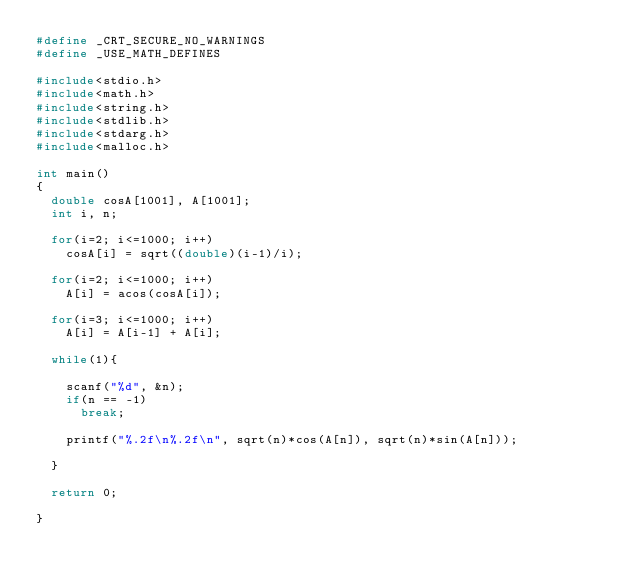<code> <loc_0><loc_0><loc_500><loc_500><_C_>#define _CRT_SECURE_NO_WARNINGS
#define _USE_MATH_DEFINES
 
#include<stdio.h>
#include<math.h>
#include<string.h>
#include<stdlib.h>
#include<stdarg.h>
#include<malloc.h>

int main()
{
	double cosA[1001], A[1001];
	int i, n;

	for(i=2; i<=1000; i++)
		cosA[i] = sqrt((double)(i-1)/i);

	for(i=2; i<=1000; i++)
		A[i] = acos(cosA[i]);

	for(i=3; i<=1000; i++)
		A[i] = A[i-1] + A[i];

	while(1){

		scanf("%d", &n);
		if(n == -1)
			break;

		printf("%.2f\n%.2f\n", sqrt(n)*cos(A[n]), sqrt(n)*sin(A[n]));

	}

	return 0;

}</code> 